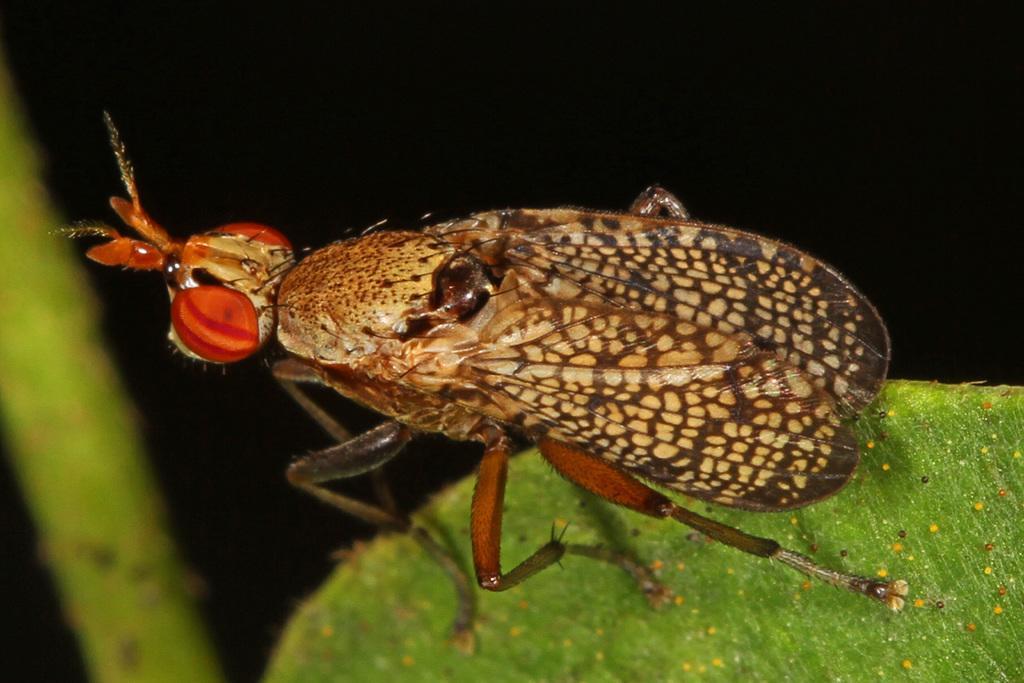Please provide a concise description of this image. In this image I can see a insect on the green leaf. Insect is in orange,brown and cream color. Background is in black color. 